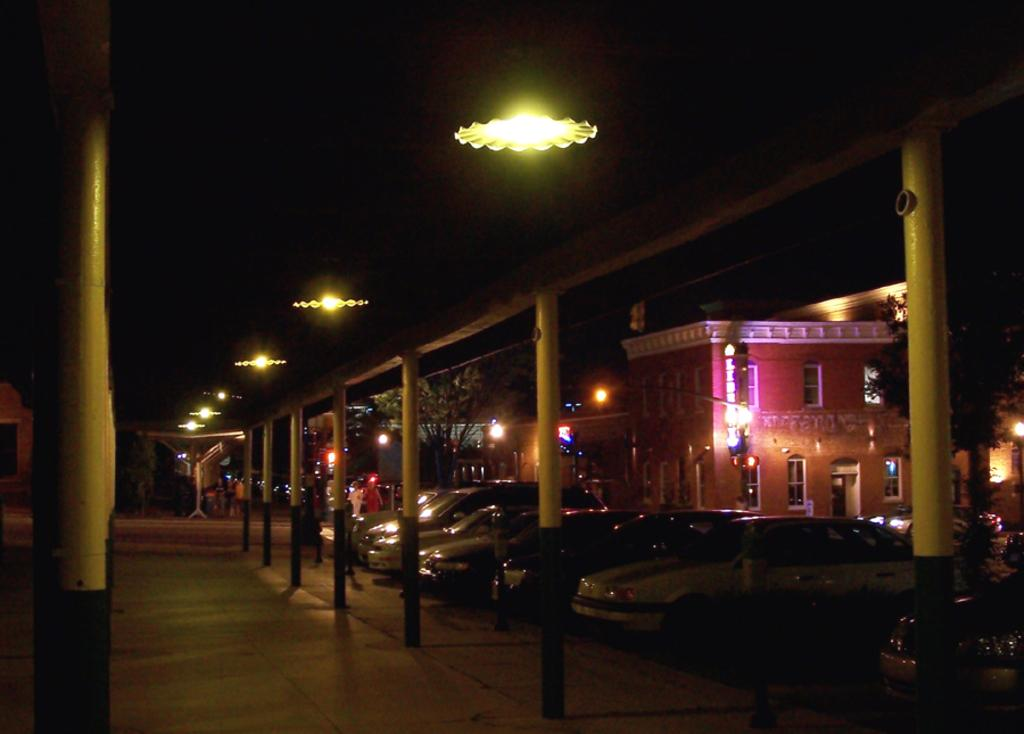What is located on the rooftop in the image? There are lights on the rooftop. What can be seen in the background of the image? There are trees, buildings, lights, windows, and vehicles visible in the background. Are there any people present in the image? Yes, there are people walking on the road on the left side. Can you hear the wave crashing in the image? There is no wave present in the image, so it is not possible to hear it crashing. What type of crate is visible in the image? There is no crate present in the image. 